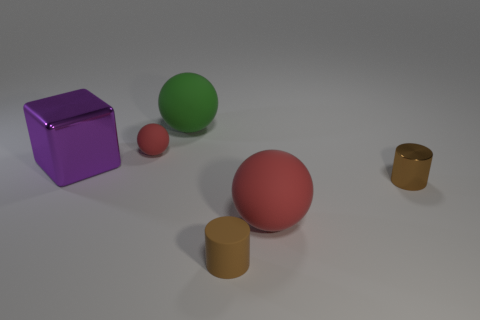Add 3 large metal things. How many objects exist? 9 Subtract all big spheres. How many spheres are left? 1 Subtract all red spheres. How many spheres are left? 1 Subtract all cylinders. How many objects are left? 4 Subtract 1 cylinders. How many cylinders are left? 1 Subtract all gray cylinders. Subtract all green cubes. How many cylinders are left? 2 Subtract all green balls. How many red cylinders are left? 0 Subtract all red matte spheres. Subtract all large red rubber cylinders. How many objects are left? 4 Add 4 purple metallic objects. How many purple metallic objects are left? 5 Add 6 small matte spheres. How many small matte spheres exist? 7 